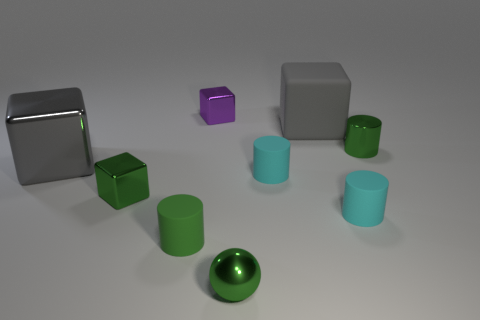What is the color of the tiny metallic thing that is to the left of the small green metallic ball and in front of the big gray matte block?
Make the answer very short. Green. Is there any other thing that has the same material as the tiny purple object?
Your answer should be very brief. Yes. Are the purple object and the cylinder that is on the left side of the small purple thing made of the same material?
Keep it short and to the point. No. There is a green cylinder that is behind the cylinder that is left of the small purple block; how big is it?
Your response must be concise. Small. Are there any other things that have the same color as the small metal cylinder?
Your answer should be very brief. Yes. Is the gray cube right of the gray shiny cube made of the same material as the green cylinder that is behind the green metallic cube?
Offer a very short reply. No. What material is the cube that is behind the big gray shiny block and to the left of the green ball?
Keep it short and to the point. Metal. Do the large gray matte thing and the small green thing that is on the left side of the tiny green matte thing have the same shape?
Provide a short and direct response. Yes. What is the cylinder that is behind the big block that is left of the tiny block in front of the purple shiny object made of?
Your answer should be very brief. Metal. What number of other things are there of the same size as the green rubber thing?
Your answer should be very brief. 6. 